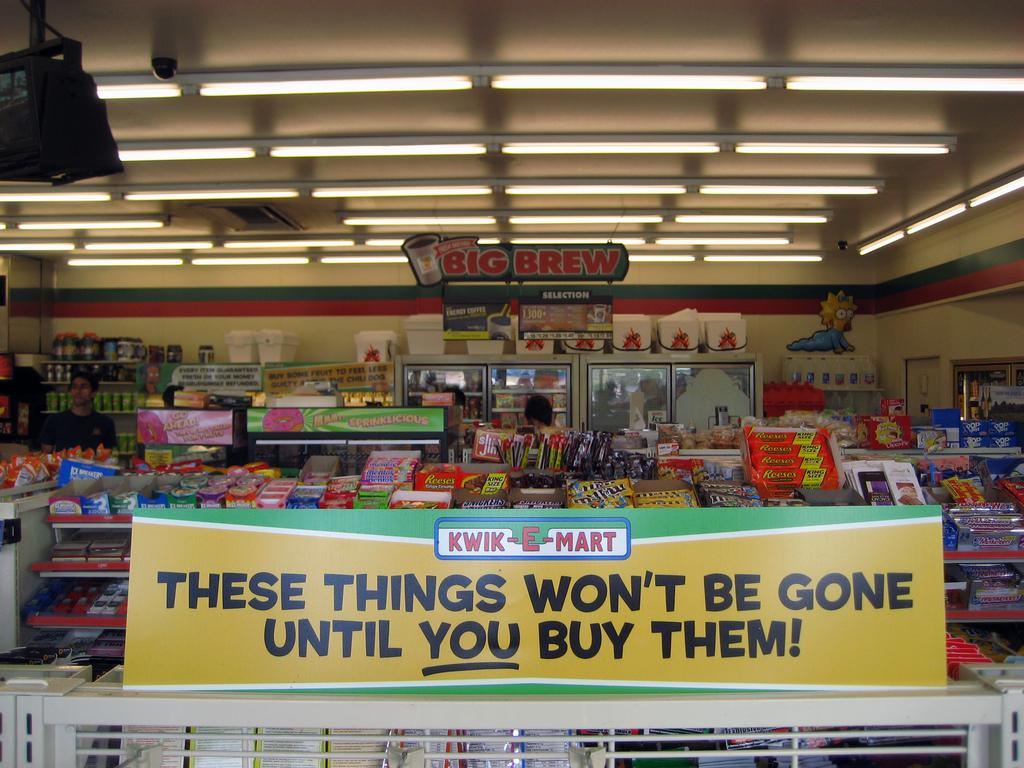<image>
Summarize the visual content of the image. A Big Brew sign is hanging from the ceiling in a store. 